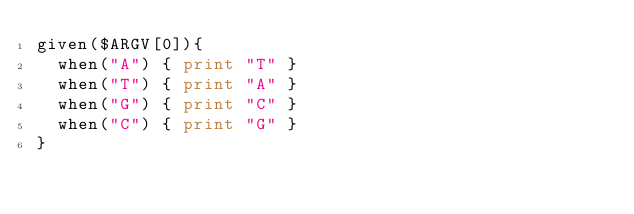Convert code to text. <code><loc_0><loc_0><loc_500><loc_500><_Perl_>given($ARGV[0]){
  when("A") { print "T" }
  when("T") { print "A" }
  when("G") { print "C" }
  when("C") { print "G" }
}</code> 